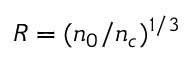<formula> <loc_0><loc_0><loc_500><loc_500>R = ( n _ { 0 } / n _ { c } ) ^ { 1 / 3 }</formula> 